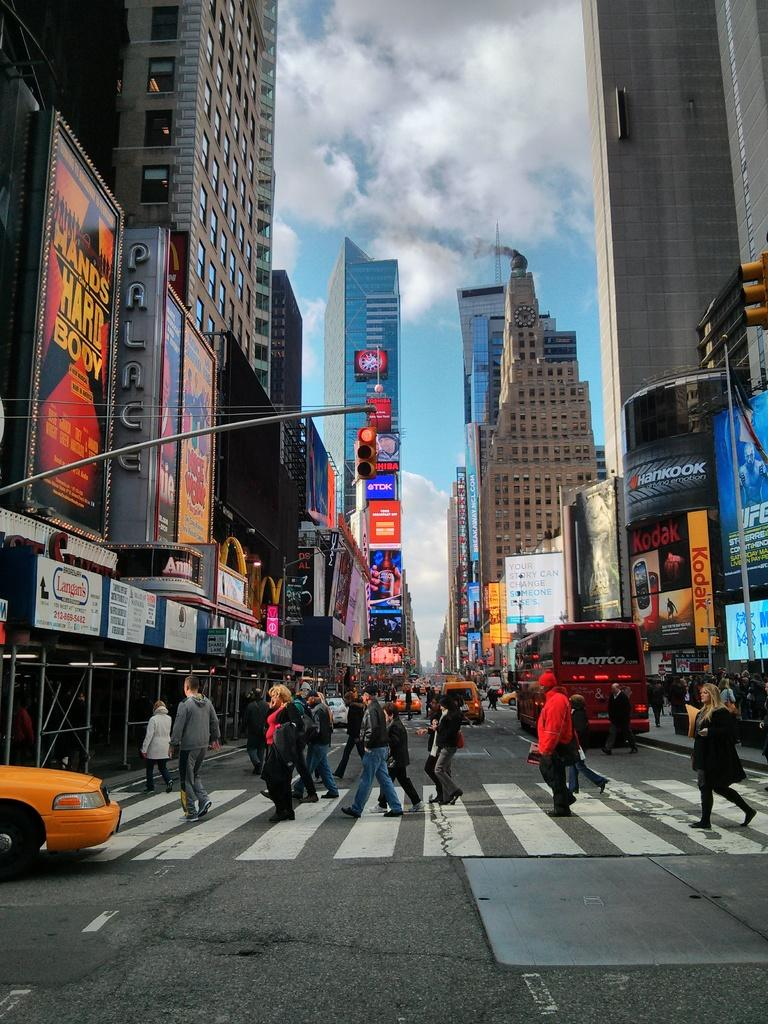Provide a one-sentence caption for the provided image. a sign that says hands on a hard body with a steet next to it. 